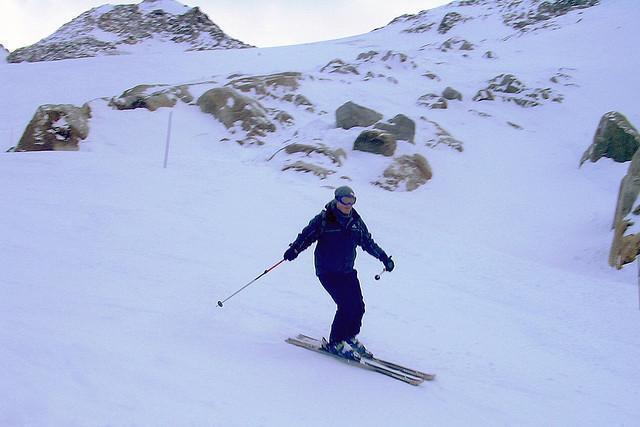How many people are in the photo?
Give a very brief answer. 1. 